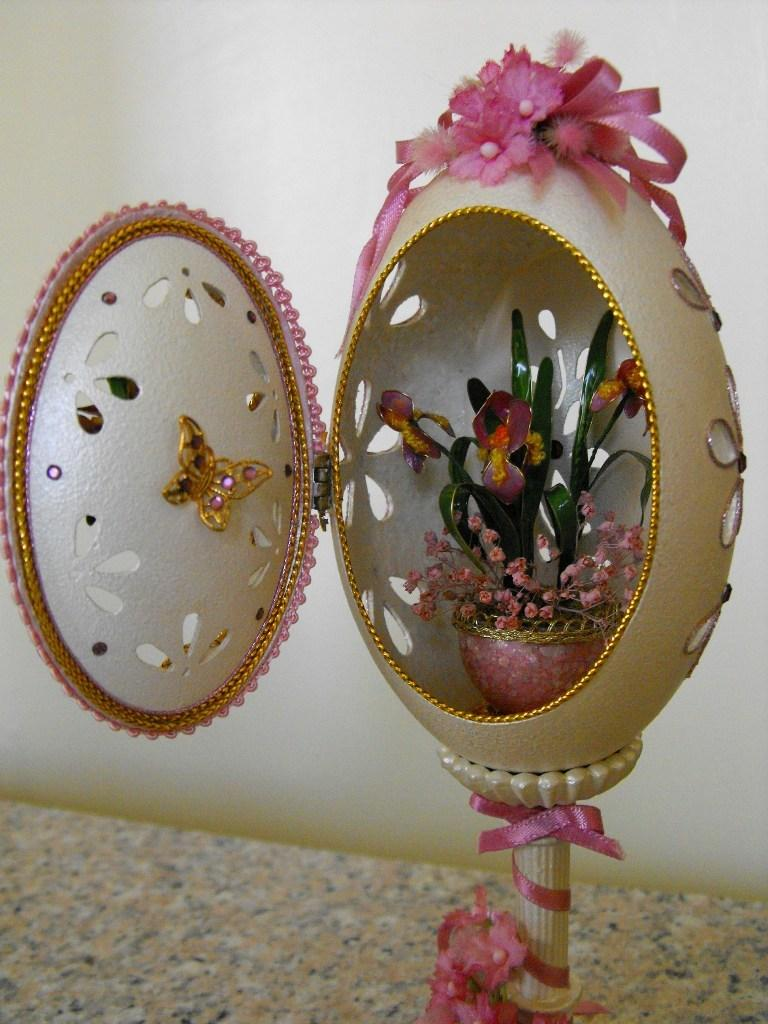What is the main object in the image? There is a flower vase in the image. What is inside the vase? There are flowers in the image. Can you describe an object that resembles an egg in the image? Yes, there is an object that resembles an egg in the image. What type of surface is at the bottom of the image? The bottom of the image has a stone surface. What can be seen in the background of the image? There is a well in the background of the image. What type of thunder can be heard in the image? There is no sound present in the image, so it is not possible to determine if any thunder can be heard. 